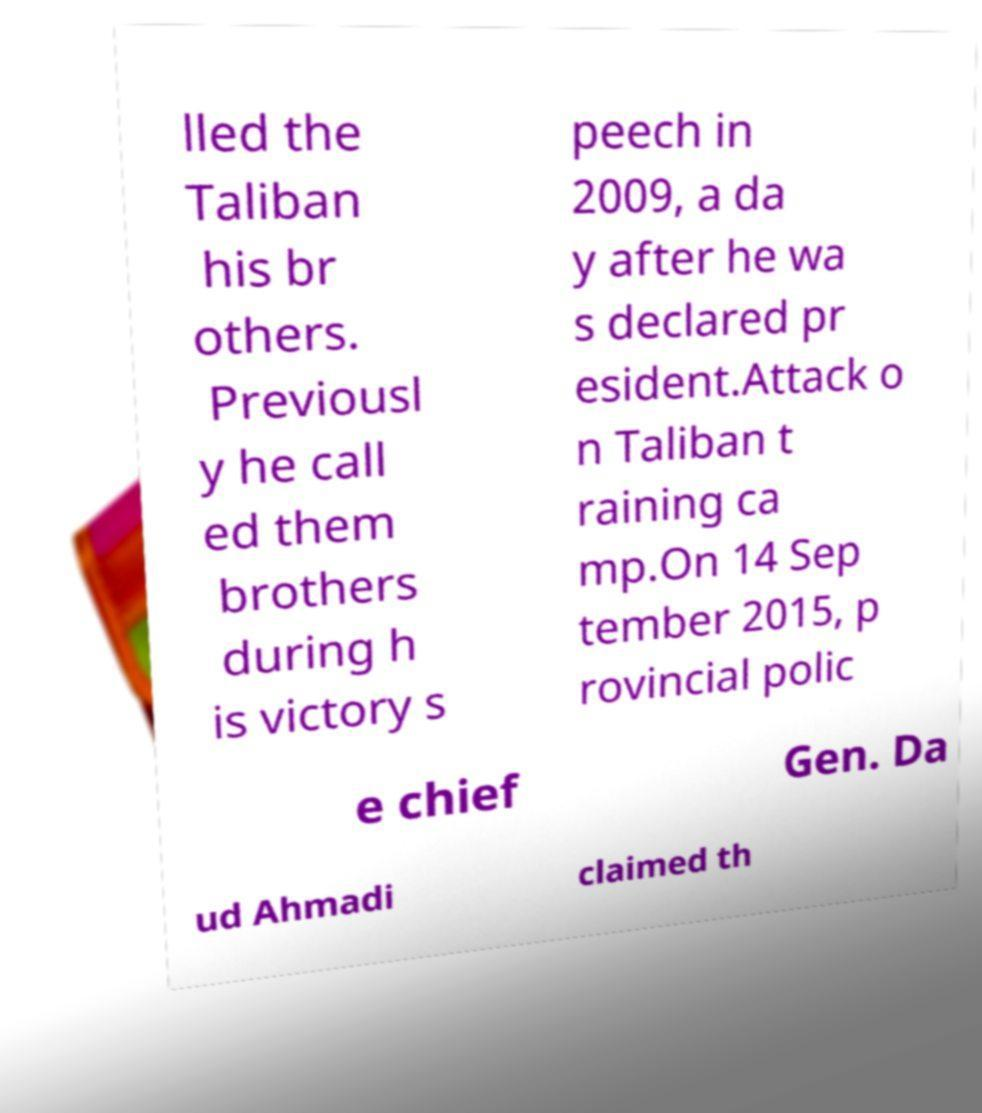There's text embedded in this image that I need extracted. Can you transcribe it verbatim? lled the Taliban his br others. Previousl y he call ed them brothers during h is victory s peech in 2009, a da y after he wa s declared pr esident.Attack o n Taliban t raining ca mp.On 14 Sep tember 2015, p rovincial polic e chief Gen. Da ud Ahmadi claimed th 